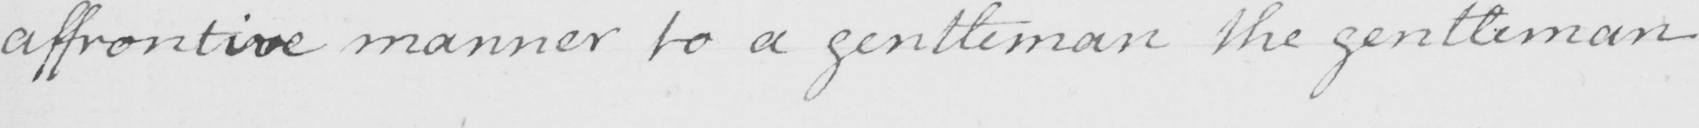Please transcribe the handwritten text in this image. affrontive manner to a gentleman the gentleman 